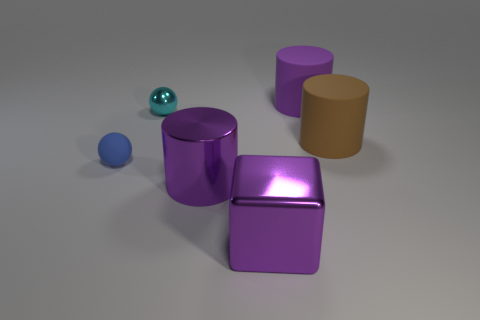Subtract all purple spheres. Subtract all purple cylinders. How many spheres are left? 2 Add 3 small blue spheres. How many objects exist? 9 Subtract all blocks. How many objects are left? 5 Add 6 gray balls. How many gray balls exist? 6 Subtract 0 yellow cubes. How many objects are left? 6 Subtract all small shiny balls. Subtract all matte balls. How many objects are left? 4 Add 3 large purple shiny things. How many large purple shiny things are left? 5 